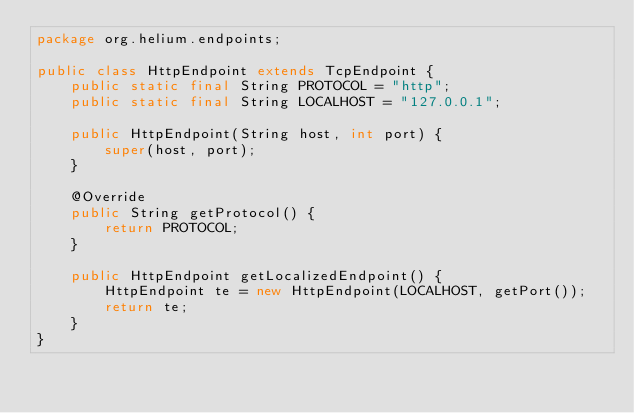<code> <loc_0><loc_0><loc_500><loc_500><_Java_>package org.helium.endpoints;

public class HttpEndpoint extends TcpEndpoint {
	public static final String PROTOCOL = "http";
	public static final String LOCALHOST = "127.0.0.1";

	public HttpEndpoint(String host, int port) {
		super(host, port);
	}

	@Override
	public String getProtocol() {
		return PROTOCOL;
	}

	public HttpEndpoint getLocalizedEndpoint() {
		HttpEndpoint te = new HttpEndpoint(LOCALHOST, getPort());
		return te;
	}
}
</code> 